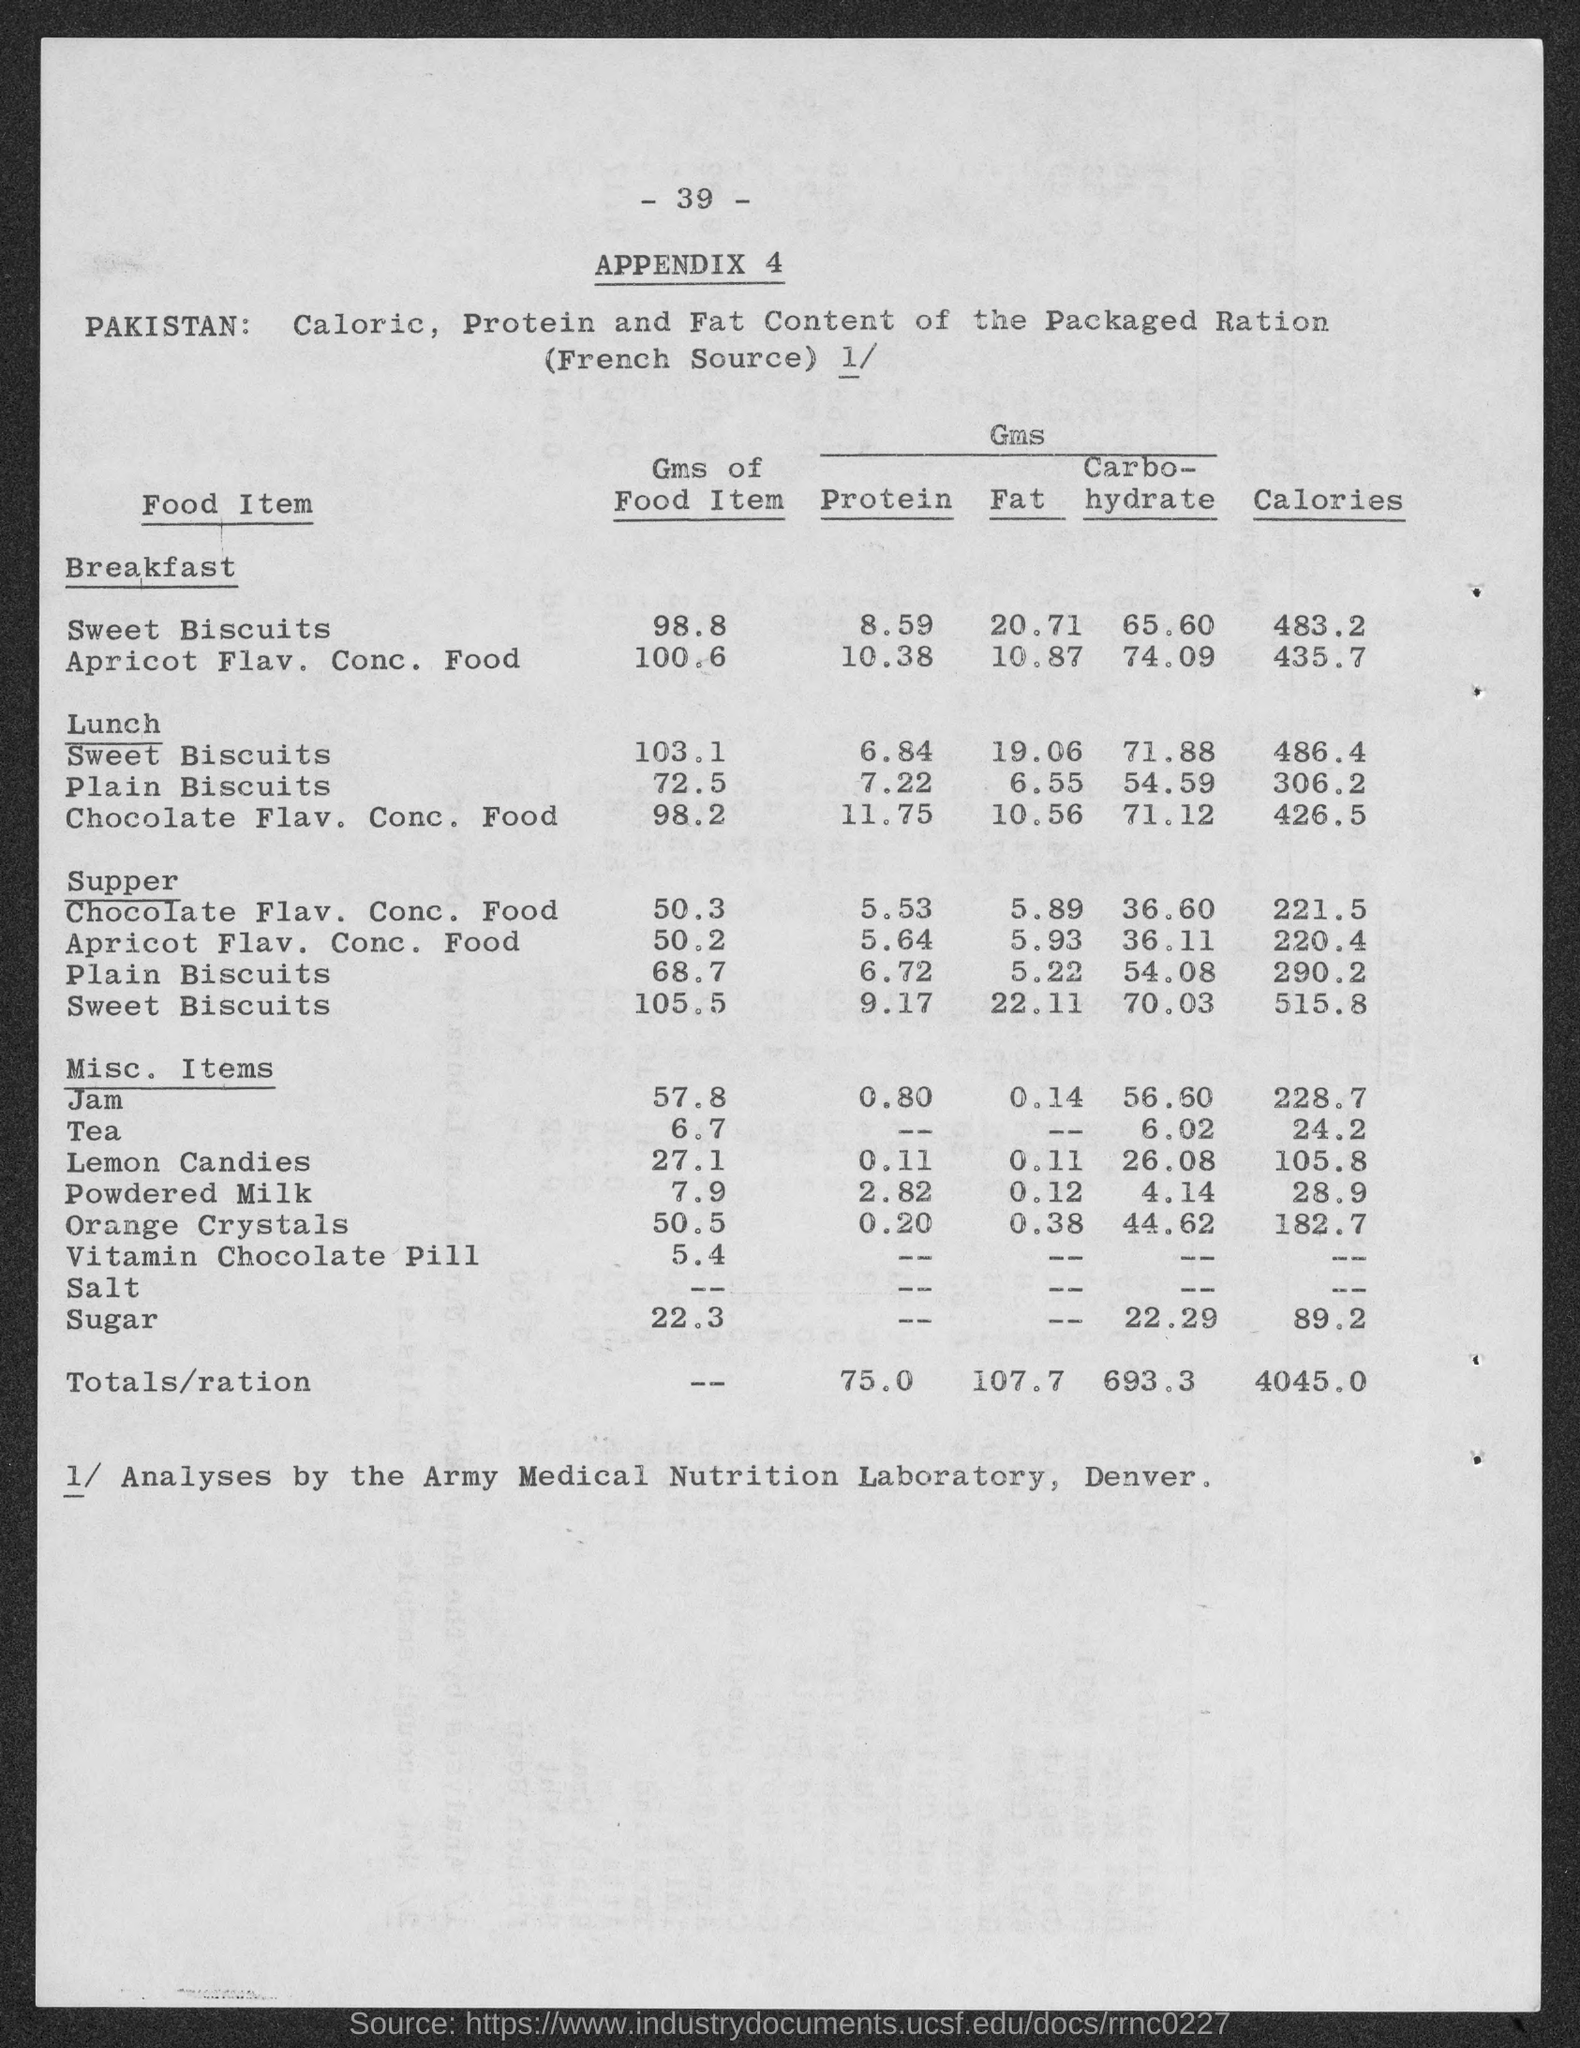What is the number at top of the page ?
Keep it short and to the point. - 39 -. 